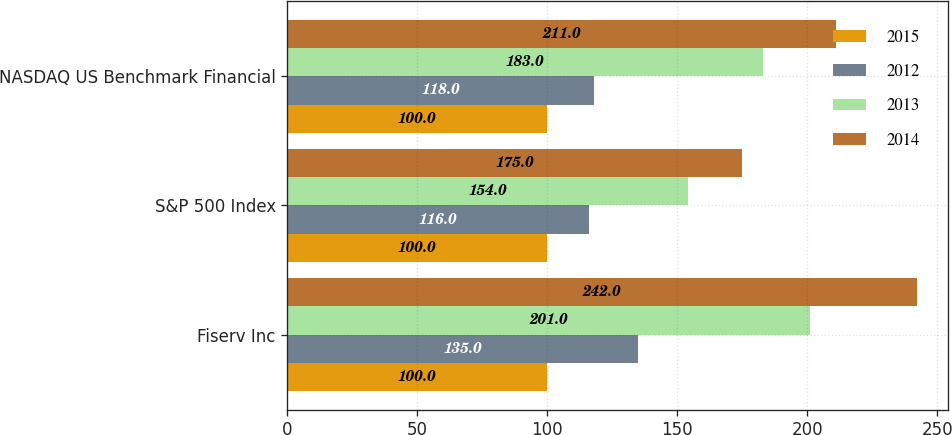Convert chart to OTSL. <chart><loc_0><loc_0><loc_500><loc_500><stacked_bar_chart><ecel><fcel>Fiserv Inc<fcel>S&P 500 Index<fcel>NASDAQ US Benchmark Financial<nl><fcel>2015<fcel>100<fcel>100<fcel>100<nl><fcel>2012<fcel>135<fcel>116<fcel>118<nl><fcel>2013<fcel>201<fcel>154<fcel>183<nl><fcel>2014<fcel>242<fcel>175<fcel>211<nl></chart> 